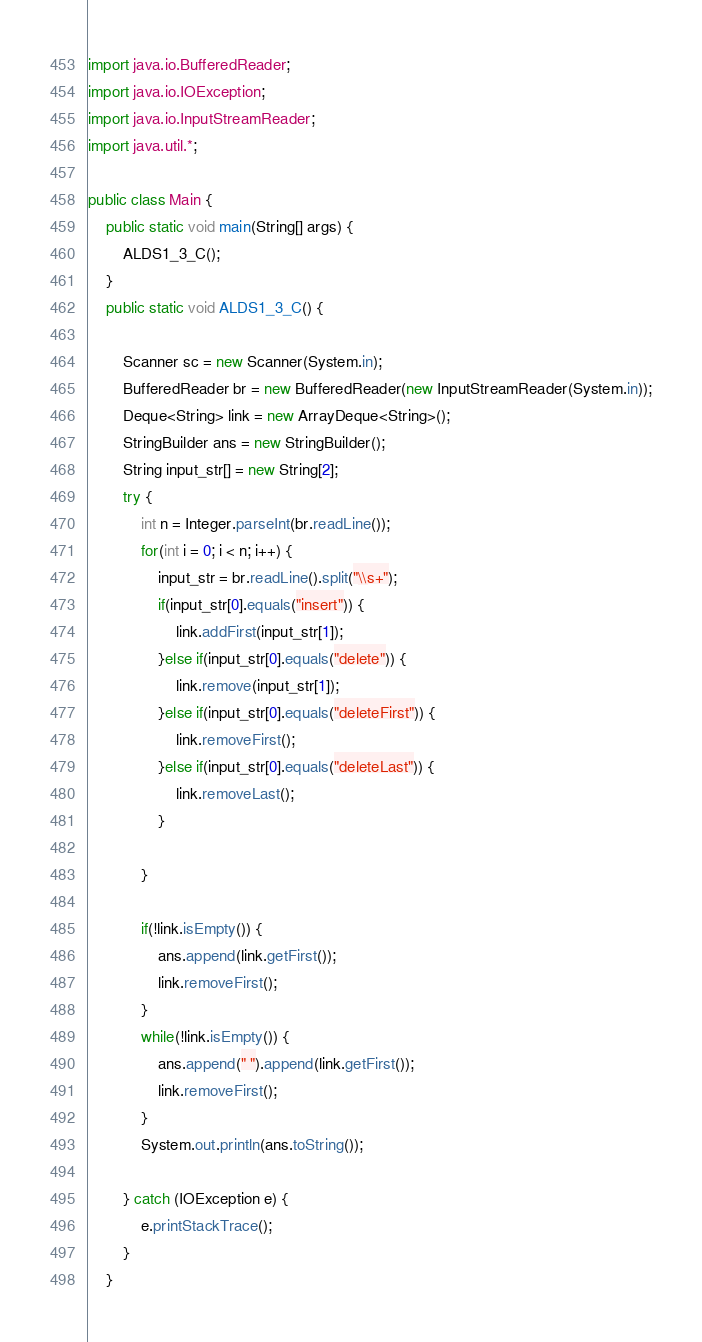<code> <loc_0><loc_0><loc_500><loc_500><_Java_>import java.io.BufferedReader;
import java.io.IOException;
import java.io.InputStreamReader;
import java.util.*;

public class Main {
	public static void main(String[] args) {
		ALDS1_3_C();
	}
	public static void ALDS1_3_C() {

		Scanner sc = new Scanner(System.in);
		BufferedReader br = new BufferedReader(new InputStreamReader(System.in));
		Deque<String> link = new ArrayDeque<String>();
		StringBuilder ans = new StringBuilder();
		String input_str[] = new String[2];
		try {
			int n = Integer.parseInt(br.readLine());
			for(int i = 0; i < n; i++) {
				input_str = br.readLine().split("\\s+");
				if(input_str[0].equals("insert")) {
					link.addFirst(input_str[1]);
				}else if(input_str[0].equals("delete")) {
					link.remove(input_str[1]);
				}else if(input_str[0].equals("deleteFirst")) {
					link.removeFirst();
				}else if(input_str[0].equals("deleteLast")) {
					link.removeLast();
				}

			}

			if(!link.isEmpty()) {
				ans.append(link.getFirst());
				link.removeFirst();
			}
			while(!link.isEmpty()) {
				ans.append(" ").append(link.getFirst());
				link.removeFirst();
			}
			System.out.println(ans.toString());
			
		} catch (IOException e) {
			e.printStackTrace();
		}
	}


</code> 